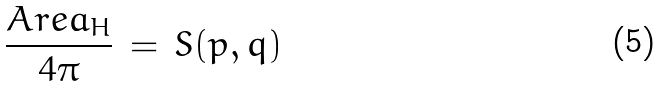<formula> <loc_0><loc_0><loc_500><loc_500>\frac { A r e a _ { H } } { 4 \pi } \, = \, S ( p , q )</formula> 